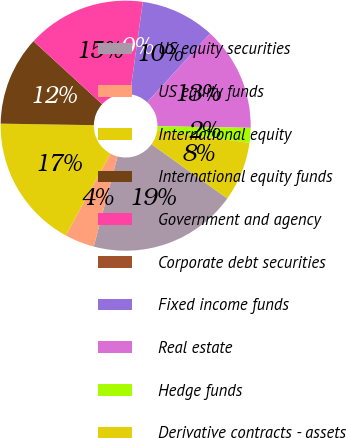Convert chart to OTSL. <chart><loc_0><loc_0><loc_500><loc_500><pie_chart><fcel>US equity securities<fcel>US equity funds<fcel>International equity<fcel>International equity funds<fcel>Government and agency<fcel>Corporate debt securities<fcel>Fixed income funds<fcel>Real estate<fcel>Hedge funds<fcel>Derivative contracts - assets<nl><fcel>19.22%<fcel>3.85%<fcel>17.3%<fcel>11.54%<fcel>15.38%<fcel>0.01%<fcel>9.62%<fcel>13.46%<fcel>1.93%<fcel>7.69%<nl></chart> 